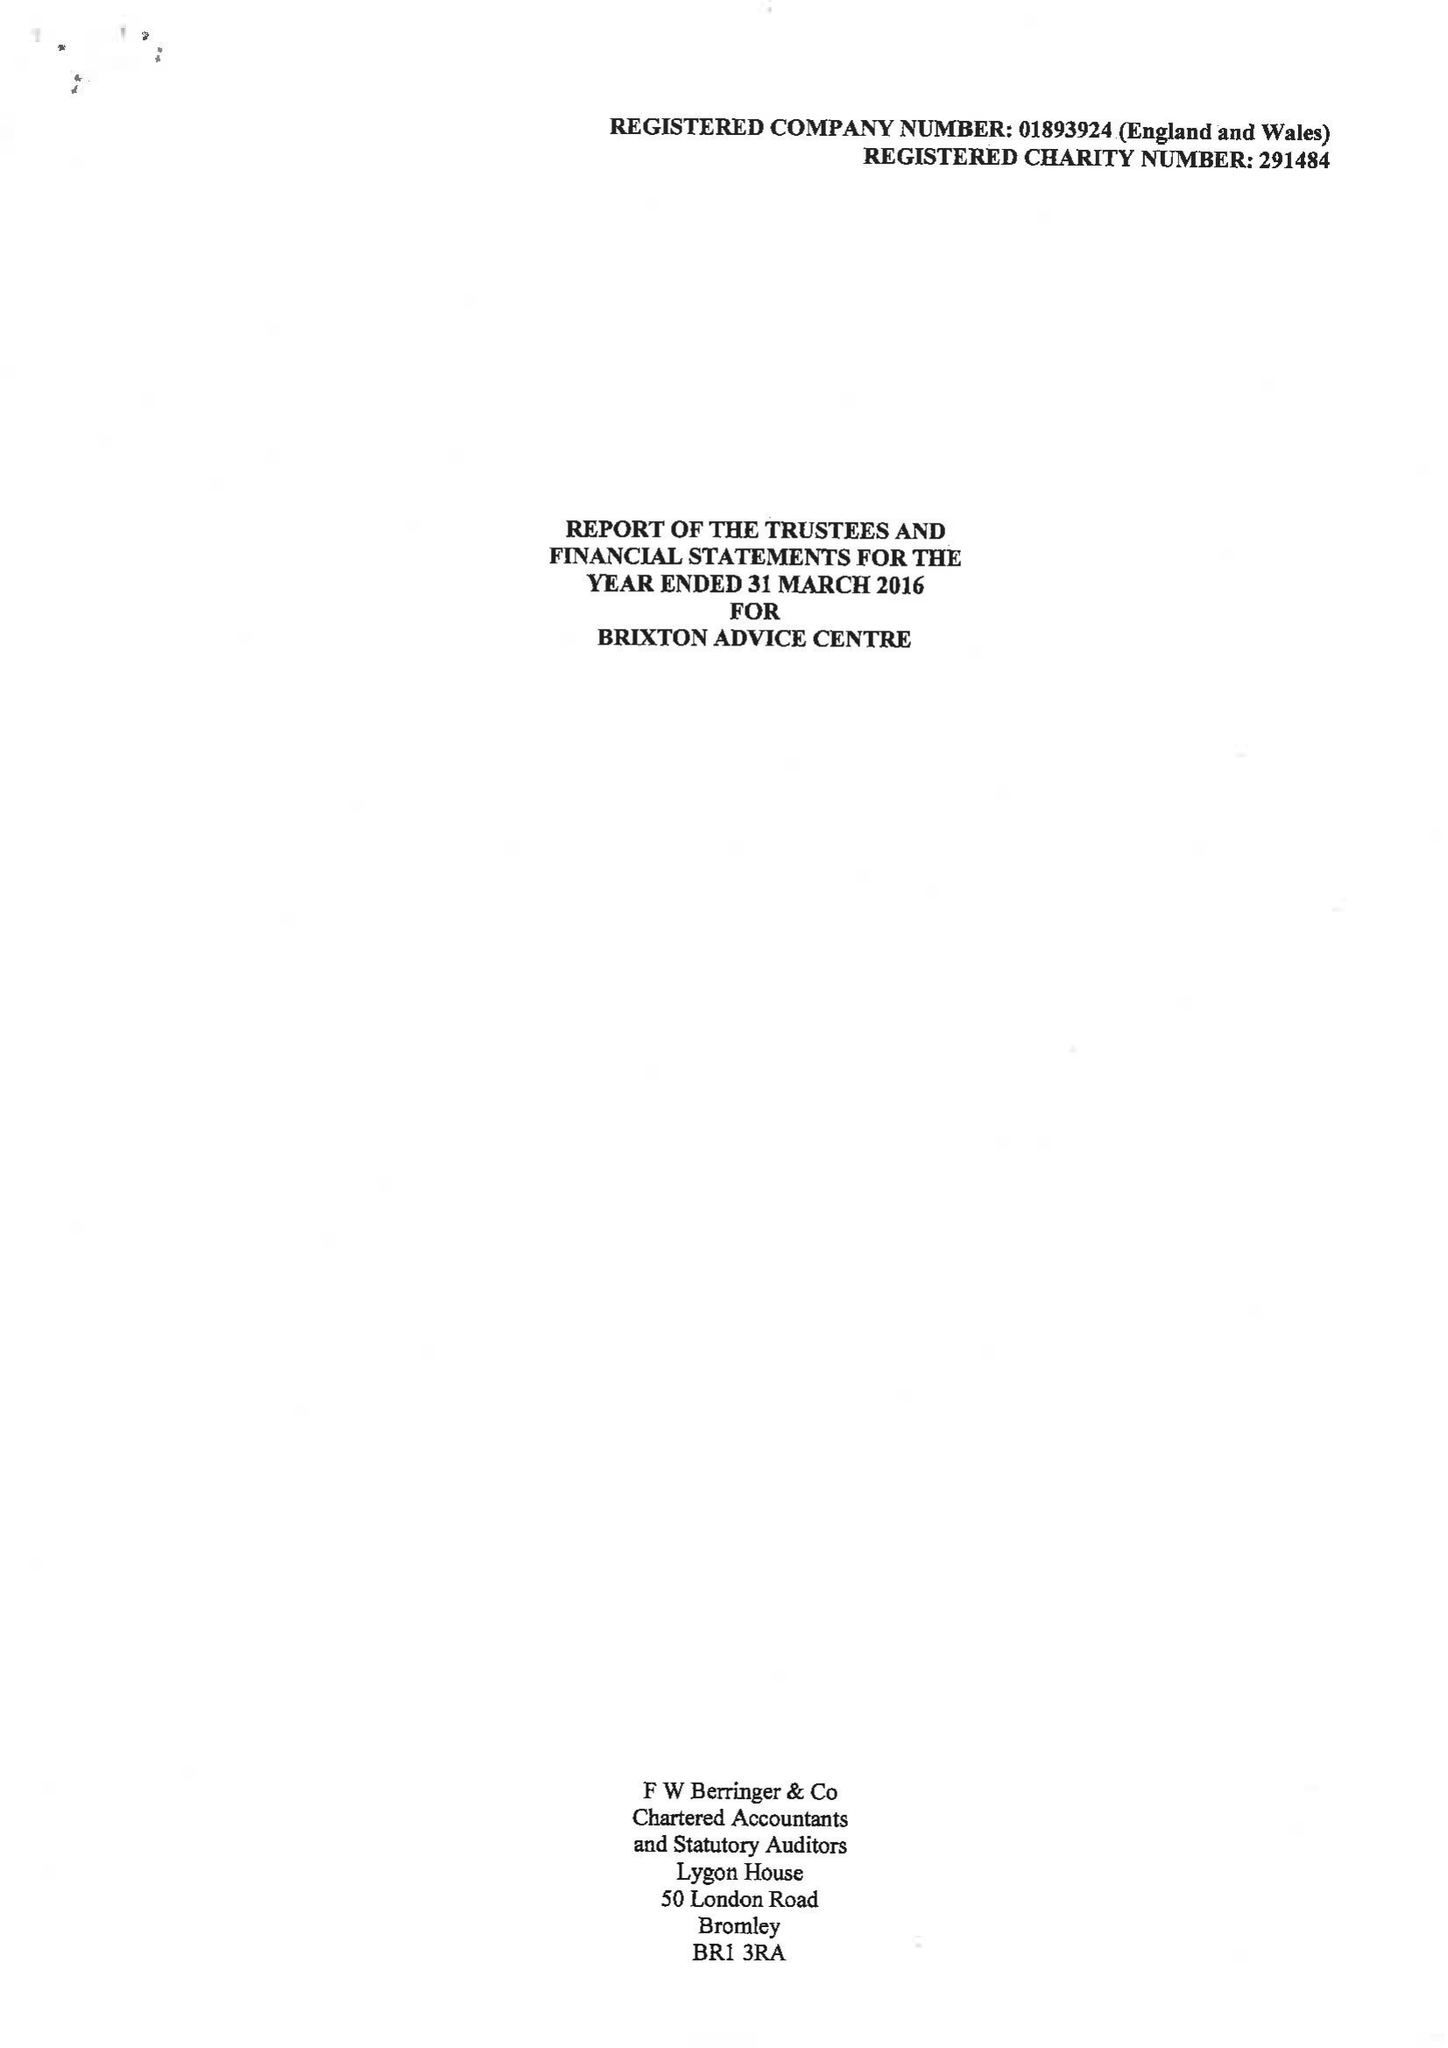What is the value for the address__post_town?
Answer the question using a single word or phrase. LONDON 